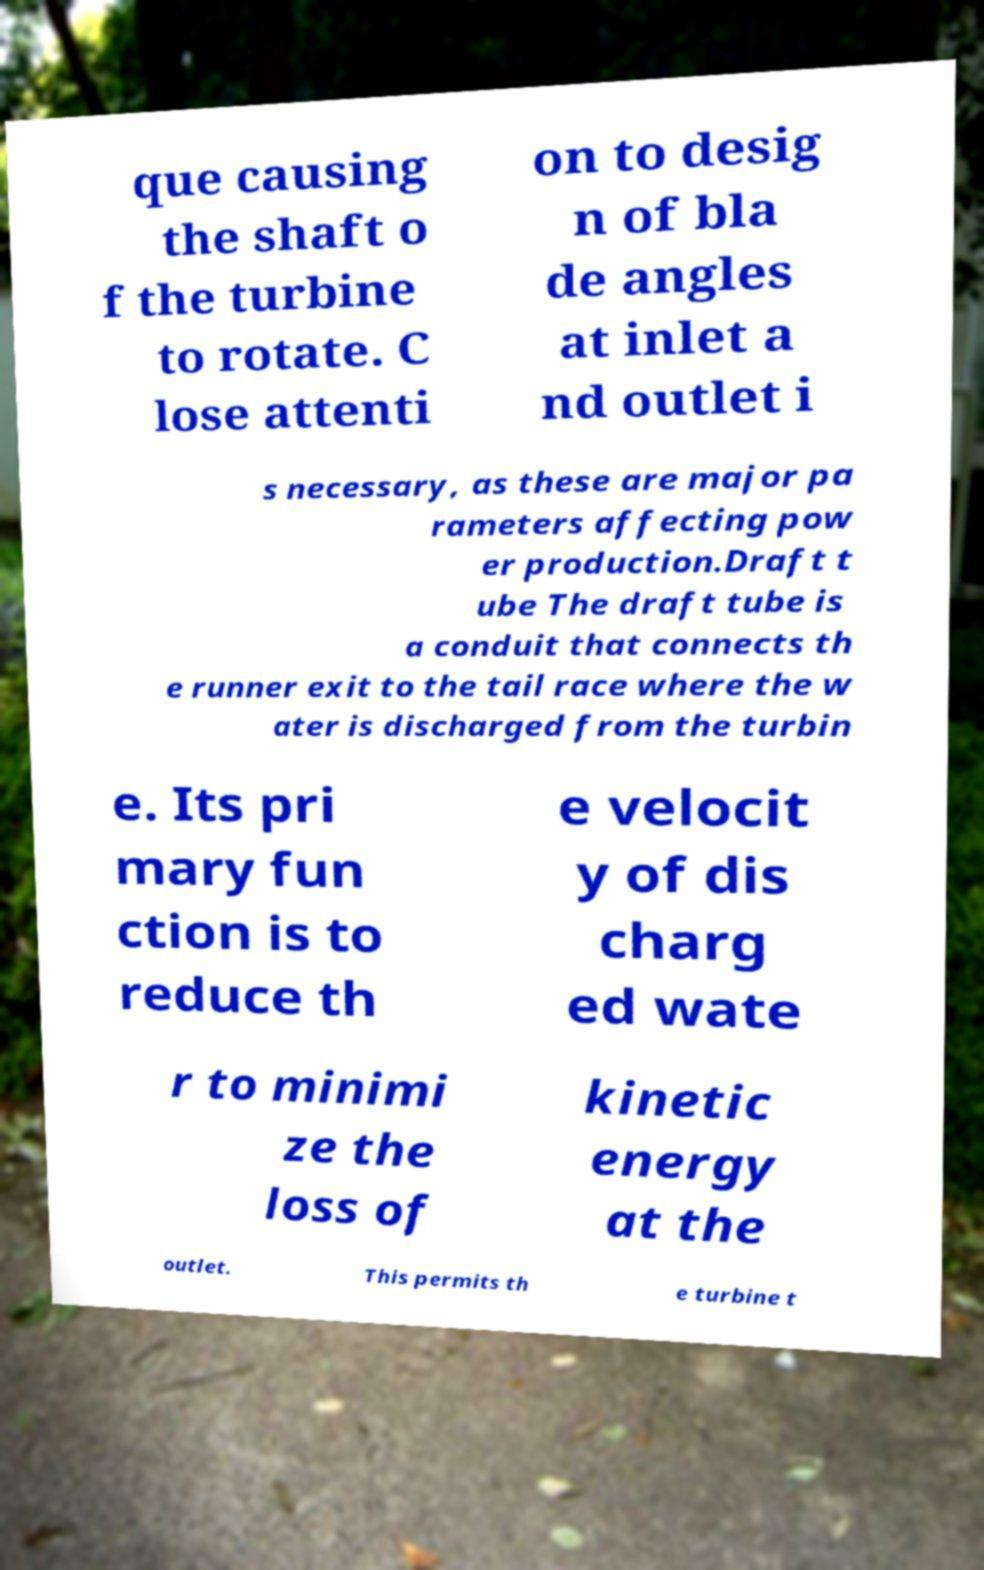There's text embedded in this image that I need extracted. Can you transcribe it verbatim? que causing the shaft o f the turbine to rotate. C lose attenti on to desig n of bla de angles at inlet a nd outlet i s necessary, as these are major pa rameters affecting pow er production.Draft t ube The draft tube is a conduit that connects th e runner exit to the tail race where the w ater is discharged from the turbin e. Its pri mary fun ction is to reduce th e velocit y of dis charg ed wate r to minimi ze the loss of kinetic energy at the outlet. This permits th e turbine t 